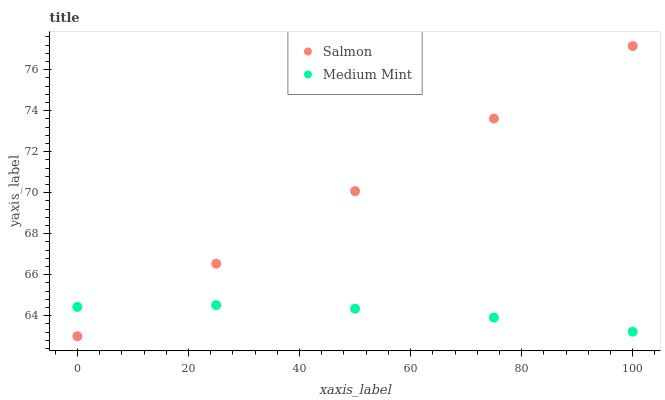Does Medium Mint have the minimum area under the curve?
Answer yes or no. Yes. Does Salmon have the maximum area under the curve?
Answer yes or no. Yes. Does Salmon have the minimum area under the curve?
Answer yes or no. No. Is Salmon the smoothest?
Answer yes or no. Yes. Is Medium Mint the roughest?
Answer yes or no. Yes. Is Salmon the roughest?
Answer yes or no. No. Does Salmon have the lowest value?
Answer yes or no. Yes. Does Salmon have the highest value?
Answer yes or no. Yes. Does Medium Mint intersect Salmon?
Answer yes or no. Yes. Is Medium Mint less than Salmon?
Answer yes or no. No. Is Medium Mint greater than Salmon?
Answer yes or no. No. 